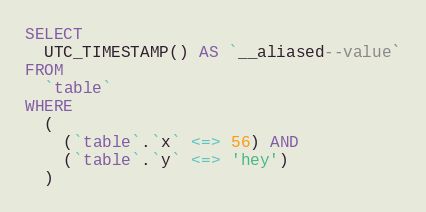<code> <loc_0><loc_0><loc_500><loc_500><_SQL_>SELECT
  UTC_TIMESTAMP() AS `__aliased--value`
FROM
  `table`
WHERE
  (
    (`table`.`x` <=> 56) AND
    (`table`.`y` <=> 'hey')
  )</code> 